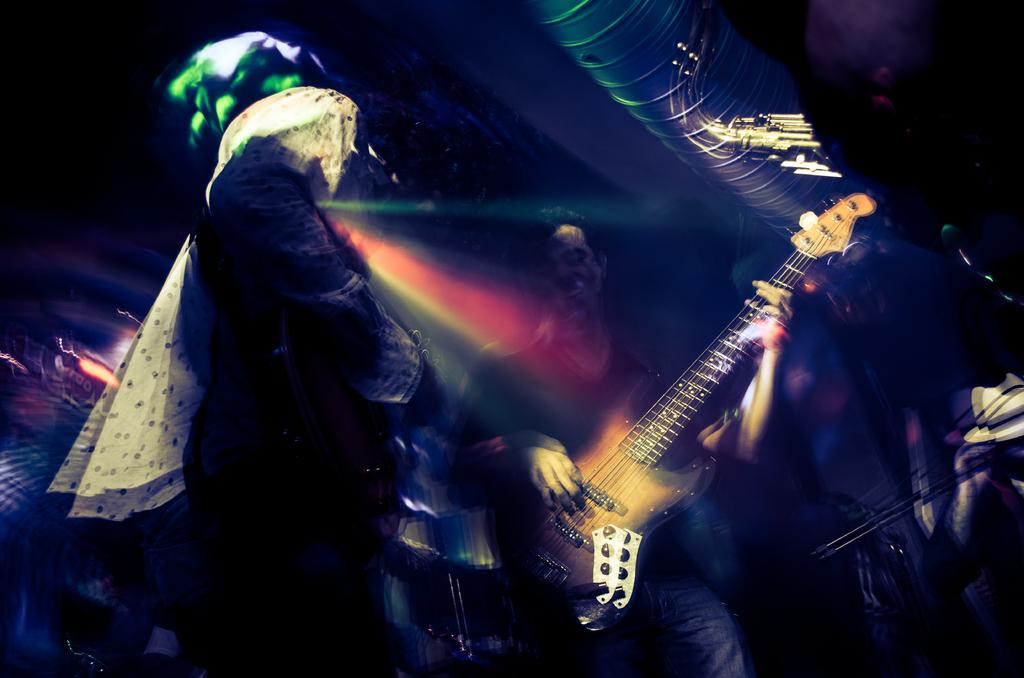How many people are in the image? There are persons in the image. What are the persons holding in their hands? The persons are holding musical instruments in their hands. What type of fruit can be seen in the hands of the persons in the image? There is no fruit present in the image; the persons are holding musical instruments. Can you hear the sound of thunder in the background of the image? There is no sound or reference to thunder in the image; it only shows persons holding musical instruments. 